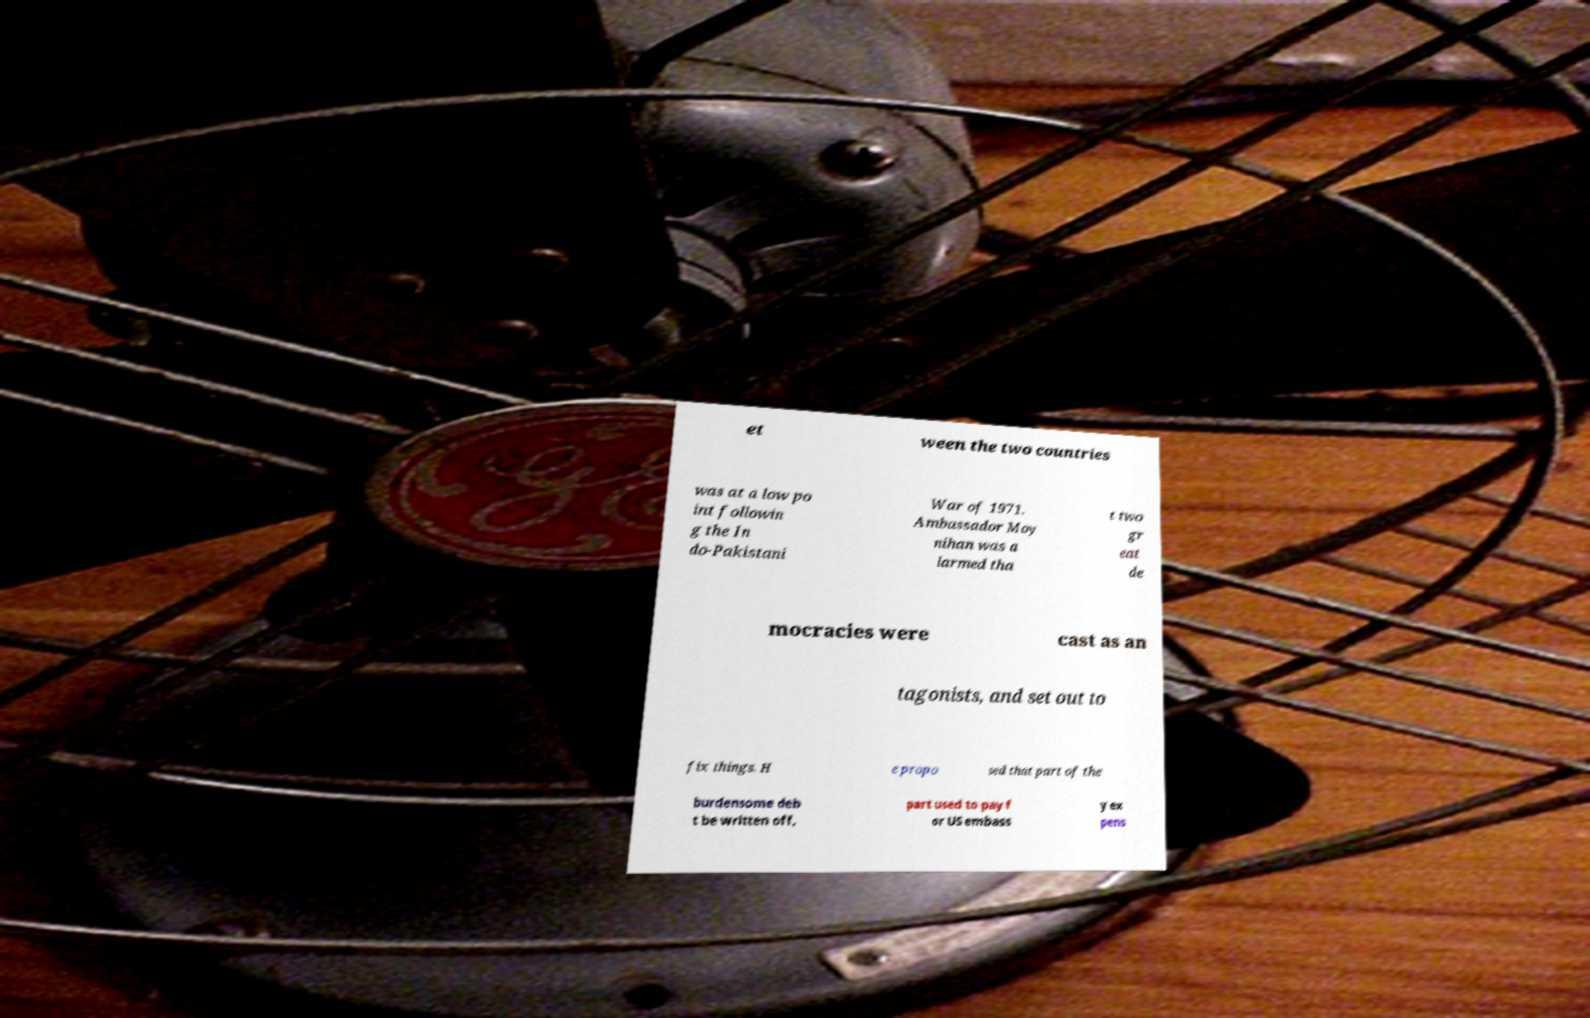Could you extract and type out the text from this image? et ween the two countries was at a low po int followin g the In do-Pakistani War of 1971. Ambassador Moy nihan was a larmed tha t two gr eat de mocracies were cast as an tagonists, and set out to fix things. H e propo sed that part of the burdensome deb t be written off, part used to pay f or US embass y ex pens 